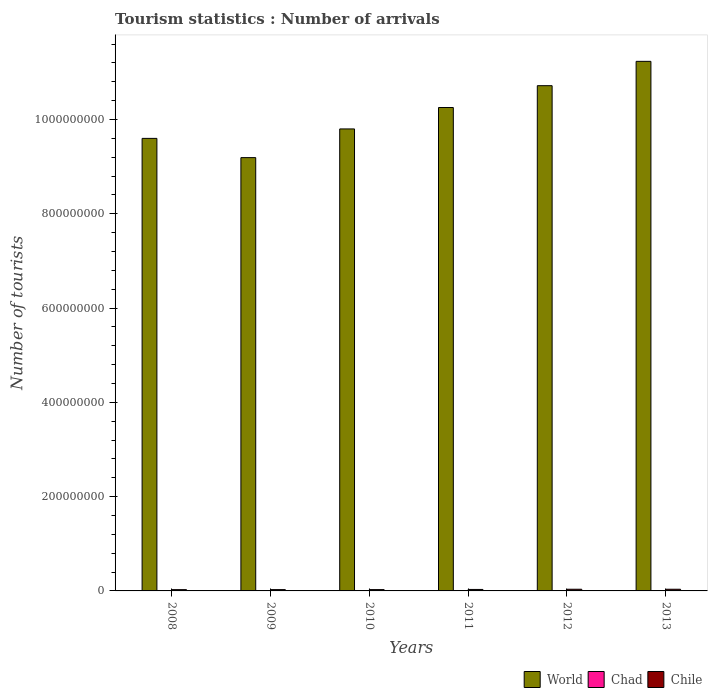Are the number of bars per tick equal to the number of legend labels?
Your answer should be compact. Yes. How many bars are there on the 4th tick from the left?
Provide a succinct answer. 3. How many bars are there on the 6th tick from the right?
Your response must be concise. 3. In how many cases, is the number of bars for a given year not equal to the number of legend labels?
Provide a short and direct response. 0. What is the number of tourist arrivals in Chad in 2012?
Provide a succinct answer. 8.60e+04. Across all years, what is the maximum number of tourist arrivals in World?
Keep it short and to the point. 1.12e+09. Across all years, what is the minimum number of tourist arrivals in Chile?
Make the answer very short. 2.71e+06. What is the total number of tourist arrivals in World in the graph?
Keep it short and to the point. 6.08e+09. What is the difference between the number of tourist arrivals in World in 2008 and that in 2012?
Make the answer very short. -1.12e+08. What is the difference between the number of tourist arrivals in Chile in 2009 and the number of tourist arrivals in Chad in 2012?
Your response must be concise. 2.67e+06. What is the average number of tourist arrivals in World per year?
Your answer should be very brief. 1.01e+09. In the year 2012, what is the difference between the number of tourist arrivals in Chad and number of tourist arrivals in Chile?
Make the answer very short. -3.47e+06. In how many years, is the number of tourist arrivals in Chile greater than 880000000?
Provide a succinct answer. 0. What is the ratio of the number of tourist arrivals in World in 2010 to that in 2011?
Provide a short and direct response. 0.96. Is the number of tourist arrivals in Chile in 2008 less than that in 2010?
Your answer should be compact. Yes. What is the difference between the highest and the second highest number of tourist arrivals in Chile?
Your response must be concise. 2.20e+04. What is the difference between the highest and the lowest number of tourist arrivals in World?
Your response must be concise. 2.04e+08. In how many years, is the number of tourist arrivals in Chile greater than the average number of tourist arrivals in Chile taken over all years?
Give a very brief answer. 3. Is the sum of the number of tourist arrivals in World in 2008 and 2011 greater than the maximum number of tourist arrivals in Chad across all years?
Ensure brevity in your answer.  Yes. What does the 3rd bar from the left in 2009 represents?
Provide a short and direct response. Chile. What is the difference between two consecutive major ticks on the Y-axis?
Your answer should be compact. 2.00e+08. Where does the legend appear in the graph?
Offer a very short reply. Bottom right. How many legend labels are there?
Your response must be concise. 3. What is the title of the graph?
Offer a very short reply. Tourism statistics : Number of arrivals. What is the label or title of the X-axis?
Offer a very short reply. Years. What is the label or title of the Y-axis?
Your answer should be very brief. Number of tourists. What is the Number of tourists of World in 2008?
Give a very brief answer. 9.60e+08. What is the Number of tourists of Chad in 2008?
Offer a terse response. 6.10e+04. What is the Number of tourists in Chile in 2008?
Your answer should be very brief. 2.71e+06. What is the Number of tourists of World in 2009?
Provide a short and direct response. 9.19e+08. What is the Number of tourists of Chile in 2009?
Offer a very short reply. 2.76e+06. What is the Number of tourists of World in 2010?
Your response must be concise. 9.80e+08. What is the Number of tourists of Chad in 2010?
Offer a terse response. 7.10e+04. What is the Number of tourists in Chile in 2010?
Provide a succinct answer. 2.80e+06. What is the Number of tourists of World in 2011?
Ensure brevity in your answer.  1.03e+09. What is the Number of tourists in Chad in 2011?
Give a very brief answer. 7.70e+04. What is the Number of tourists in Chile in 2011?
Ensure brevity in your answer.  3.14e+06. What is the Number of tourists in World in 2012?
Offer a terse response. 1.07e+09. What is the Number of tourists in Chad in 2012?
Give a very brief answer. 8.60e+04. What is the Number of tourists in Chile in 2012?
Offer a very short reply. 3.55e+06. What is the Number of tourists of World in 2013?
Ensure brevity in your answer.  1.12e+09. What is the Number of tourists in Chad in 2013?
Provide a succinct answer. 1.00e+05. What is the Number of tourists in Chile in 2013?
Your answer should be very brief. 3.58e+06. Across all years, what is the maximum Number of tourists in World?
Your response must be concise. 1.12e+09. Across all years, what is the maximum Number of tourists of Chile?
Provide a short and direct response. 3.58e+06. Across all years, what is the minimum Number of tourists in World?
Give a very brief answer. 9.19e+08. Across all years, what is the minimum Number of tourists of Chad?
Keep it short and to the point. 6.10e+04. Across all years, what is the minimum Number of tourists in Chile?
Ensure brevity in your answer.  2.71e+06. What is the total Number of tourists of World in the graph?
Provide a short and direct response. 6.08e+09. What is the total Number of tourists of Chad in the graph?
Provide a succinct answer. 4.65e+05. What is the total Number of tourists of Chile in the graph?
Your answer should be compact. 1.85e+07. What is the difference between the Number of tourists in World in 2008 and that in 2009?
Offer a terse response. 4.08e+07. What is the difference between the Number of tourists in Chad in 2008 and that in 2009?
Your answer should be compact. -9000. What is the difference between the Number of tourists of World in 2008 and that in 2010?
Your answer should be compact. -2.01e+07. What is the difference between the Number of tourists of Chile in 2008 and that in 2010?
Give a very brief answer. -9.10e+04. What is the difference between the Number of tourists in World in 2008 and that in 2011?
Provide a succinct answer. -6.55e+07. What is the difference between the Number of tourists of Chad in 2008 and that in 2011?
Your answer should be compact. -1.60e+04. What is the difference between the Number of tourists in Chile in 2008 and that in 2011?
Provide a short and direct response. -4.27e+05. What is the difference between the Number of tourists in World in 2008 and that in 2012?
Offer a terse response. -1.12e+08. What is the difference between the Number of tourists in Chad in 2008 and that in 2012?
Provide a short and direct response. -2.50e+04. What is the difference between the Number of tourists in Chile in 2008 and that in 2012?
Provide a succinct answer. -8.44e+05. What is the difference between the Number of tourists of World in 2008 and that in 2013?
Offer a very short reply. -1.63e+08. What is the difference between the Number of tourists in Chad in 2008 and that in 2013?
Offer a terse response. -3.90e+04. What is the difference between the Number of tourists in Chile in 2008 and that in 2013?
Provide a short and direct response. -8.66e+05. What is the difference between the Number of tourists of World in 2009 and that in 2010?
Make the answer very short. -6.09e+07. What is the difference between the Number of tourists in Chad in 2009 and that in 2010?
Keep it short and to the point. -1000. What is the difference between the Number of tourists of Chile in 2009 and that in 2010?
Your response must be concise. -4.10e+04. What is the difference between the Number of tourists of World in 2009 and that in 2011?
Make the answer very short. -1.06e+08. What is the difference between the Number of tourists in Chad in 2009 and that in 2011?
Provide a succinct answer. -7000. What is the difference between the Number of tourists in Chile in 2009 and that in 2011?
Ensure brevity in your answer.  -3.77e+05. What is the difference between the Number of tourists in World in 2009 and that in 2012?
Offer a very short reply. -1.53e+08. What is the difference between the Number of tourists in Chad in 2009 and that in 2012?
Give a very brief answer. -1.60e+04. What is the difference between the Number of tourists of Chile in 2009 and that in 2012?
Provide a short and direct response. -7.94e+05. What is the difference between the Number of tourists in World in 2009 and that in 2013?
Make the answer very short. -2.04e+08. What is the difference between the Number of tourists of Chad in 2009 and that in 2013?
Offer a very short reply. -3.00e+04. What is the difference between the Number of tourists of Chile in 2009 and that in 2013?
Ensure brevity in your answer.  -8.16e+05. What is the difference between the Number of tourists in World in 2010 and that in 2011?
Make the answer very short. -4.54e+07. What is the difference between the Number of tourists of Chad in 2010 and that in 2011?
Offer a very short reply. -6000. What is the difference between the Number of tourists in Chile in 2010 and that in 2011?
Your response must be concise. -3.36e+05. What is the difference between the Number of tourists in World in 2010 and that in 2012?
Keep it short and to the point. -9.17e+07. What is the difference between the Number of tourists in Chad in 2010 and that in 2012?
Ensure brevity in your answer.  -1.50e+04. What is the difference between the Number of tourists of Chile in 2010 and that in 2012?
Keep it short and to the point. -7.53e+05. What is the difference between the Number of tourists of World in 2010 and that in 2013?
Your response must be concise. -1.43e+08. What is the difference between the Number of tourists in Chad in 2010 and that in 2013?
Make the answer very short. -2.90e+04. What is the difference between the Number of tourists in Chile in 2010 and that in 2013?
Your answer should be very brief. -7.75e+05. What is the difference between the Number of tourists of World in 2011 and that in 2012?
Your response must be concise. -4.63e+07. What is the difference between the Number of tourists in Chad in 2011 and that in 2012?
Provide a succinct answer. -9000. What is the difference between the Number of tourists of Chile in 2011 and that in 2012?
Provide a succinct answer. -4.17e+05. What is the difference between the Number of tourists in World in 2011 and that in 2013?
Offer a terse response. -9.79e+07. What is the difference between the Number of tourists in Chad in 2011 and that in 2013?
Your response must be concise. -2.30e+04. What is the difference between the Number of tourists in Chile in 2011 and that in 2013?
Provide a short and direct response. -4.39e+05. What is the difference between the Number of tourists in World in 2012 and that in 2013?
Ensure brevity in your answer.  -5.16e+07. What is the difference between the Number of tourists in Chad in 2012 and that in 2013?
Give a very brief answer. -1.40e+04. What is the difference between the Number of tourists of Chile in 2012 and that in 2013?
Your answer should be very brief. -2.20e+04. What is the difference between the Number of tourists in World in 2008 and the Number of tourists in Chad in 2009?
Keep it short and to the point. 9.60e+08. What is the difference between the Number of tourists of World in 2008 and the Number of tourists of Chile in 2009?
Offer a very short reply. 9.57e+08. What is the difference between the Number of tourists of Chad in 2008 and the Number of tourists of Chile in 2009?
Ensure brevity in your answer.  -2.70e+06. What is the difference between the Number of tourists in World in 2008 and the Number of tourists in Chad in 2010?
Give a very brief answer. 9.60e+08. What is the difference between the Number of tourists of World in 2008 and the Number of tourists of Chile in 2010?
Your answer should be very brief. 9.57e+08. What is the difference between the Number of tourists of Chad in 2008 and the Number of tourists of Chile in 2010?
Provide a short and direct response. -2.74e+06. What is the difference between the Number of tourists in World in 2008 and the Number of tourists in Chad in 2011?
Provide a succinct answer. 9.60e+08. What is the difference between the Number of tourists of World in 2008 and the Number of tourists of Chile in 2011?
Your response must be concise. 9.57e+08. What is the difference between the Number of tourists of Chad in 2008 and the Number of tourists of Chile in 2011?
Make the answer very short. -3.08e+06. What is the difference between the Number of tourists of World in 2008 and the Number of tourists of Chad in 2012?
Your answer should be very brief. 9.60e+08. What is the difference between the Number of tourists of World in 2008 and the Number of tourists of Chile in 2012?
Your response must be concise. 9.56e+08. What is the difference between the Number of tourists in Chad in 2008 and the Number of tourists in Chile in 2012?
Make the answer very short. -3.49e+06. What is the difference between the Number of tourists in World in 2008 and the Number of tourists in Chad in 2013?
Make the answer very short. 9.60e+08. What is the difference between the Number of tourists in World in 2008 and the Number of tourists in Chile in 2013?
Provide a short and direct response. 9.56e+08. What is the difference between the Number of tourists in Chad in 2008 and the Number of tourists in Chile in 2013?
Offer a very short reply. -3.52e+06. What is the difference between the Number of tourists of World in 2009 and the Number of tourists of Chad in 2010?
Make the answer very short. 9.19e+08. What is the difference between the Number of tourists of World in 2009 and the Number of tourists of Chile in 2010?
Your response must be concise. 9.16e+08. What is the difference between the Number of tourists in Chad in 2009 and the Number of tourists in Chile in 2010?
Provide a succinct answer. -2.73e+06. What is the difference between the Number of tourists of World in 2009 and the Number of tourists of Chad in 2011?
Offer a very short reply. 9.19e+08. What is the difference between the Number of tourists of World in 2009 and the Number of tourists of Chile in 2011?
Your answer should be very brief. 9.16e+08. What is the difference between the Number of tourists of Chad in 2009 and the Number of tourists of Chile in 2011?
Keep it short and to the point. -3.07e+06. What is the difference between the Number of tourists in World in 2009 and the Number of tourists in Chad in 2012?
Your answer should be very brief. 9.19e+08. What is the difference between the Number of tourists in World in 2009 and the Number of tourists in Chile in 2012?
Provide a succinct answer. 9.15e+08. What is the difference between the Number of tourists of Chad in 2009 and the Number of tourists of Chile in 2012?
Provide a short and direct response. -3.48e+06. What is the difference between the Number of tourists of World in 2009 and the Number of tourists of Chad in 2013?
Offer a very short reply. 9.19e+08. What is the difference between the Number of tourists of World in 2009 and the Number of tourists of Chile in 2013?
Provide a short and direct response. 9.15e+08. What is the difference between the Number of tourists in Chad in 2009 and the Number of tourists in Chile in 2013?
Your answer should be very brief. -3.51e+06. What is the difference between the Number of tourists in World in 2010 and the Number of tourists in Chad in 2011?
Keep it short and to the point. 9.80e+08. What is the difference between the Number of tourists in World in 2010 and the Number of tourists in Chile in 2011?
Your answer should be very brief. 9.77e+08. What is the difference between the Number of tourists in Chad in 2010 and the Number of tourists in Chile in 2011?
Ensure brevity in your answer.  -3.07e+06. What is the difference between the Number of tourists of World in 2010 and the Number of tourists of Chad in 2012?
Your response must be concise. 9.80e+08. What is the difference between the Number of tourists of World in 2010 and the Number of tourists of Chile in 2012?
Make the answer very short. 9.76e+08. What is the difference between the Number of tourists in Chad in 2010 and the Number of tourists in Chile in 2012?
Ensure brevity in your answer.  -3.48e+06. What is the difference between the Number of tourists in World in 2010 and the Number of tourists in Chad in 2013?
Your answer should be compact. 9.80e+08. What is the difference between the Number of tourists of World in 2010 and the Number of tourists of Chile in 2013?
Offer a very short reply. 9.76e+08. What is the difference between the Number of tourists of Chad in 2010 and the Number of tourists of Chile in 2013?
Make the answer very short. -3.50e+06. What is the difference between the Number of tourists in World in 2011 and the Number of tourists in Chad in 2012?
Give a very brief answer. 1.03e+09. What is the difference between the Number of tourists of World in 2011 and the Number of tourists of Chile in 2012?
Offer a terse response. 1.02e+09. What is the difference between the Number of tourists in Chad in 2011 and the Number of tourists in Chile in 2012?
Your answer should be compact. -3.48e+06. What is the difference between the Number of tourists in World in 2011 and the Number of tourists in Chad in 2013?
Offer a very short reply. 1.03e+09. What is the difference between the Number of tourists of World in 2011 and the Number of tourists of Chile in 2013?
Offer a terse response. 1.02e+09. What is the difference between the Number of tourists in Chad in 2011 and the Number of tourists in Chile in 2013?
Provide a succinct answer. -3.50e+06. What is the difference between the Number of tourists in World in 2012 and the Number of tourists in Chad in 2013?
Ensure brevity in your answer.  1.07e+09. What is the difference between the Number of tourists in World in 2012 and the Number of tourists in Chile in 2013?
Provide a short and direct response. 1.07e+09. What is the difference between the Number of tourists of Chad in 2012 and the Number of tourists of Chile in 2013?
Your answer should be very brief. -3.49e+06. What is the average Number of tourists in World per year?
Give a very brief answer. 1.01e+09. What is the average Number of tourists in Chad per year?
Your response must be concise. 7.75e+04. What is the average Number of tourists of Chile per year?
Provide a succinct answer. 3.09e+06. In the year 2008, what is the difference between the Number of tourists in World and Number of tourists in Chad?
Provide a succinct answer. 9.60e+08. In the year 2008, what is the difference between the Number of tourists of World and Number of tourists of Chile?
Provide a short and direct response. 9.57e+08. In the year 2008, what is the difference between the Number of tourists in Chad and Number of tourists in Chile?
Provide a succinct answer. -2.65e+06. In the year 2009, what is the difference between the Number of tourists of World and Number of tourists of Chad?
Offer a terse response. 9.19e+08. In the year 2009, what is the difference between the Number of tourists in World and Number of tourists in Chile?
Make the answer very short. 9.16e+08. In the year 2009, what is the difference between the Number of tourists of Chad and Number of tourists of Chile?
Provide a succinct answer. -2.69e+06. In the year 2010, what is the difference between the Number of tourists in World and Number of tourists in Chad?
Offer a very short reply. 9.80e+08. In the year 2010, what is the difference between the Number of tourists in World and Number of tourists in Chile?
Provide a succinct answer. 9.77e+08. In the year 2010, what is the difference between the Number of tourists in Chad and Number of tourists in Chile?
Offer a terse response. -2.73e+06. In the year 2011, what is the difference between the Number of tourists of World and Number of tourists of Chad?
Your answer should be compact. 1.03e+09. In the year 2011, what is the difference between the Number of tourists of World and Number of tourists of Chile?
Your response must be concise. 1.02e+09. In the year 2011, what is the difference between the Number of tourists in Chad and Number of tourists in Chile?
Offer a very short reply. -3.06e+06. In the year 2012, what is the difference between the Number of tourists of World and Number of tourists of Chad?
Give a very brief answer. 1.07e+09. In the year 2012, what is the difference between the Number of tourists in World and Number of tourists in Chile?
Your response must be concise. 1.07e+09. In the year 2012, what is the difference between the Number of tourists of Chad and Number of tourists of Chile?
Offer a very short reply. -3.47e+06. In the year 2013, what is the difference between the Number of tourists in World and Number of tourists in Chad?
Keep it short and to the point. 1.12e+09. In the year 2013, what is the difference between the Number of tourists of World and Number of tourists of Chile?
Ensure brevity in your answer.  1.12e+09. In the year 2013, what is the difference between the Number of tourists of Chad and Number of tourists of Chile?
Give a very brief answer. -3.48e+06. What is the ratio of the Number of tourists of World in 2008 to that in 2009?
Offer a very short reply. 1.04. What is the ratio of the Number of tourists in Chad in 2008 to that in 2009?
Offer a terse response. 0.87. What is the ratio of the Number of tourists of Chile in 2008 to that in 2009?
Make the answer very short. 0.98. What is the ratio of the Number of tourists of World in 2008 to that in 2010?
Keep it short and to the point. 0.98. What is the ratio of the Number of tourists of Chad in 2008 to that in 2010?
Give a very brief answer. 0.86. What is the ratio of the Number of tourists in Chile in 2008 to that in 2010?
Make the answer very short. 0.97. What is the ratio of the Number of tourists of World in 2008 to that in 2011?
Make the answer very short. 0.94. What is the ratio of the Number of tourists of Chad in 2008 to that in 2011?
Offer a very short reply. 0.79. What is the ratio of the Number of tourists of Chile in 2008 to that in 2011?
Offer a very short reply. 0.86. What is the ratio of the Number of tourists in World in 2008 to that in 2012?
Give a very brief answer. 0.9. What is the ratio of the Number of tourists in Chad in 2008 to that in 2012?
Your answer should be compact. 0.71. What is the ratio of the Number of tourists of Chile in 2008 to that in 2012?
Your answer should be very brief. 0.76. What is the ratio of the Number of tourists in World in 2008 to that in 2013?
Keep it short and to the point. 0.85. What is the ratio of the Number of tourists of Chad in 2008 to that in 2013?
Your answer should be compact. 0.61. What is the ratio of the Number of tourists of Chile in 2008 to that in 2013?
Give a very brief answer. 0.76. What is the ratio of the Number of tourists of World in 2009 to that in 2010?
Make the answer very short. 0.94. What is the ratio of the Number of tourists of Chad in 2009 to that in 2010?
Keep it short and to the point. 0.99. What is the ratio of the Number of tourists in Chile in 2009 to that in 2010?
Your response must be concise. 0.99. What is the ratio of the Number of tourists in World in 2009 to that in 2011?
Keep it short and to the point. 0.9. What is the ratio of the Number of tourists of Chile in 2009 to that in 2011?
Offer a very short reply. 0.88. What is the ratio of the Number of tourists of World in 2009 to that in 2012?
Provide a succinct answer. 0.86. What is the ratio of the Number of tourists of Chad in 2009 to that in 2012?
Provide a short and direct response. 0.81. What is the ratio of the Number of tourists in Chile in 2009 to that in 2012?
Provide a succinct answer. 0.78. What is the ratio of the Number of tourists in World in 2009 to that in 2013?
Keep it short and to the point. 0.82. What is the ratio of the Number of tourists of Chile in 2009 to that in 2013?
Offer a terse response. 0.77. What is the ratio of the Number of tourists of World in 2010 to that in 2011?
Keep it short and to the point. 0.96. What is the ratio of the Number of tourists of Chad in 2010 to that in 2011?
Your answer should be very brief. 0.92. What is the ratio of the Number of tourists of Chile in 2010 to that in 2011?
Provide a succinct answer. 0.89. What is the ratio of the Number of tourists of World in 2010 to that in 2012?
Offer a very short reply. 0.91. What is the ratio of the Number of tourists in Chad in 2010 to that in 2012?
Your response must be concise. 0.83. What is the ratio of the Number of tourists in Chile in 2010 to that in 2012?
Make the answer very short. 0.79. What is the ratio of the Number of tourists in World in 2010 to that in 2013?
Offer a very short reply. 0.87. What is the ratio of the Number of tourists in Chad in 2010 to that in 2013?
Make the answer very short. 0.71. What is the ratio of the Number of tourists of Chile in 2010 to that in 2013?
Your answer should be very brief. 0.78. What is the ratio of the Number of tourists of World in 2011 to that in 2012?
Keep it short and to the point. 0.96. What is the ratio of the Number of tourists in Chad in 2011 to that in 2012?
Make the answer very short. 0.9. What is the ratio of the Number of tourists of Chile in 2011 to that in 2012?
Offer a terse response. 0.88. What is the ratio of the Number of tourists in World in 2011 to that in 2013?
Your answer should be very brief. 0.91. What is the ratio of the Number of tourists in Chad in 2011 to that in 2013?
Provide a succinct answer. 0.77. What is the ratio of the Number of tourists of Chile in 2011 to that in 2013?
Your answer should be compact. 0.88. What is the ratio of the Number of tourists in World in 2012 to that in 2013?
Ensure brevity in your answer.  0.95. What is the ratio of the Number of tourists in Chad in 2012 to that in 2013?
Offer a very short reply. 0.86. What is the ratio of the Number of tourists in Chile in 2012 to that in 2013?
Your answer should be very brief. 0.99. What is the difference between the highest and the second highest Number of tourists in World?
Provide a succinct answer. 5.16e+07. What is the difference between the highest and the second highest Number of tourists of Chad?
Your answer should be very brief. 1.40e+04. What is the difference between the highest and the second highest Number of tourists in Chile?
Ensure brevity in your answer.  2.20e+04. What is the difference between the highest and the lowest Number of tourists of World?
Your answer should be compact. 2.04e+08. What is the difference between the highest and the lowest Number of tourists in Chad?
Offer a very short reply. 3.90e+04. What is the difference between the highest and the lowest Number of tourists in Chile?
Your answer should be very brief. 8.66e+05. 